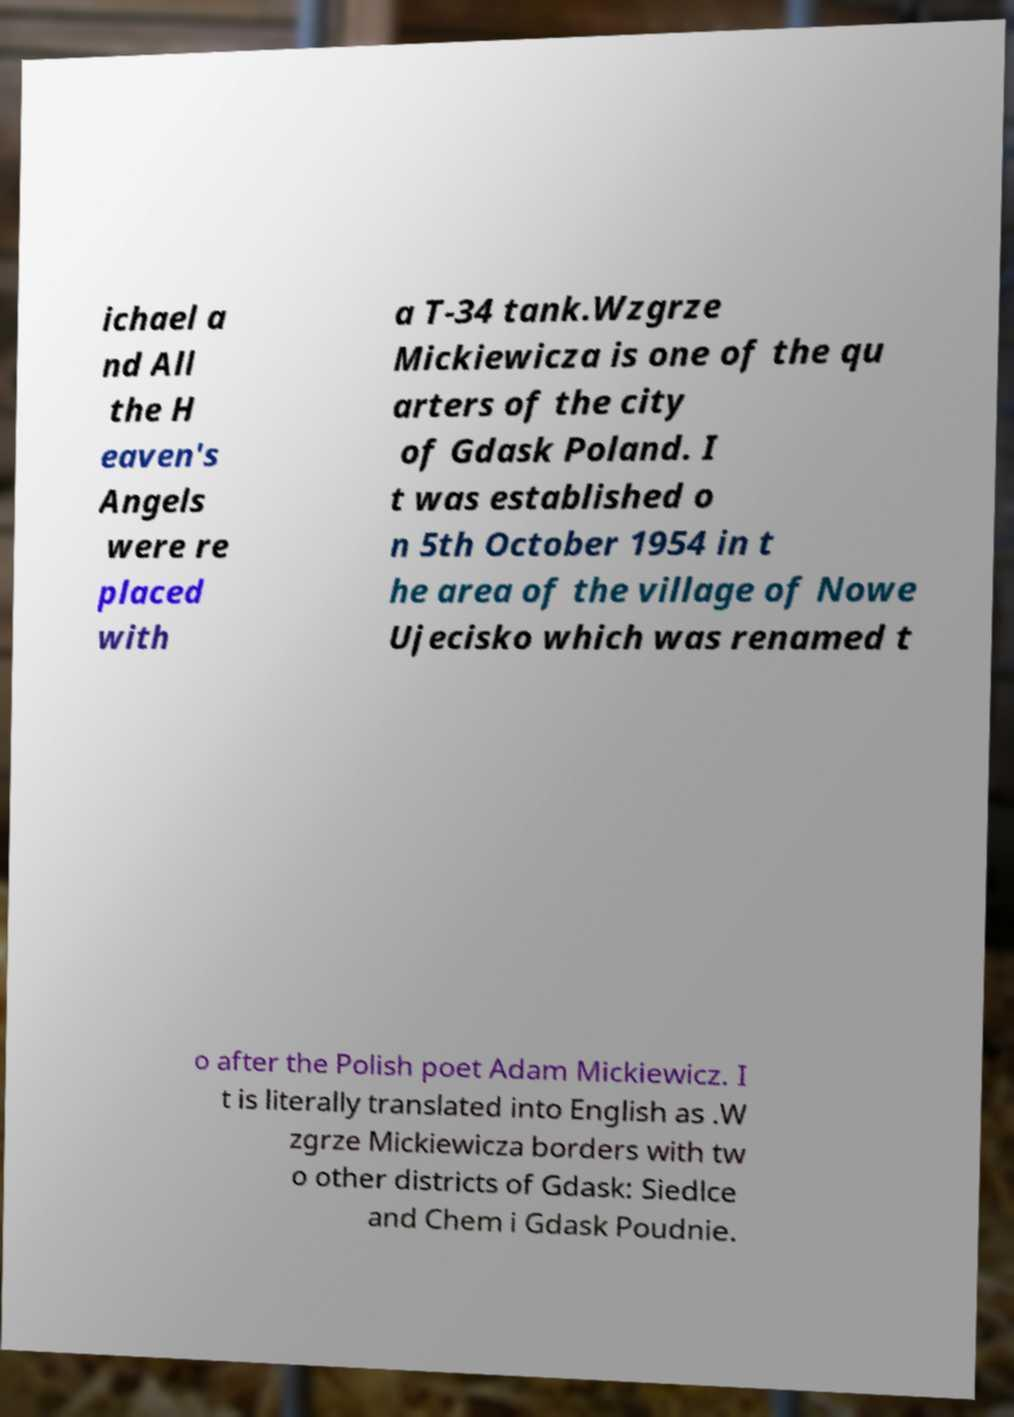What messages or text are displayed in this image? I need them in a readable, typed format. ichael a nd All the H eaven's Angels were re placed with a T-34 tank.Wzgrze Mickiewicza is one of the qu arters of the city of Gdask Poland. I t was established o n 5th October 1954 in t he area of the village of Nowe Ujecisko which was renamed t o after the Polish poet Adam Mickiewicz. I t is literally translated into English as .W zgrze Mickiewicza borders with tw o other districts of Gdask: Siedlce and Chem i Gdask Poudnie. 